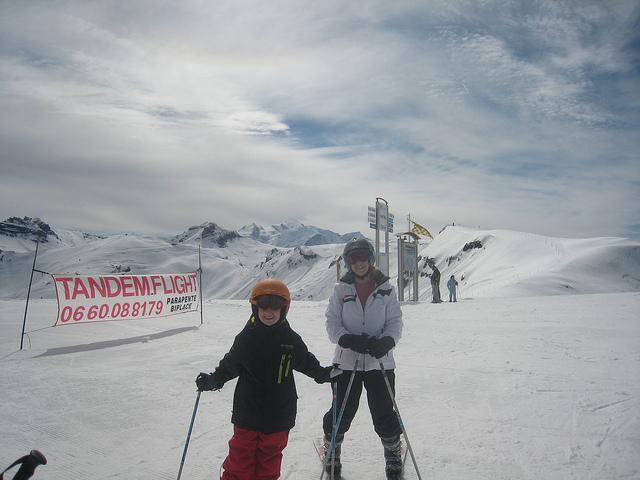What type of activity is this?

Choices:
A) winter
B) aquatic
C) summer
D) tropical winter 